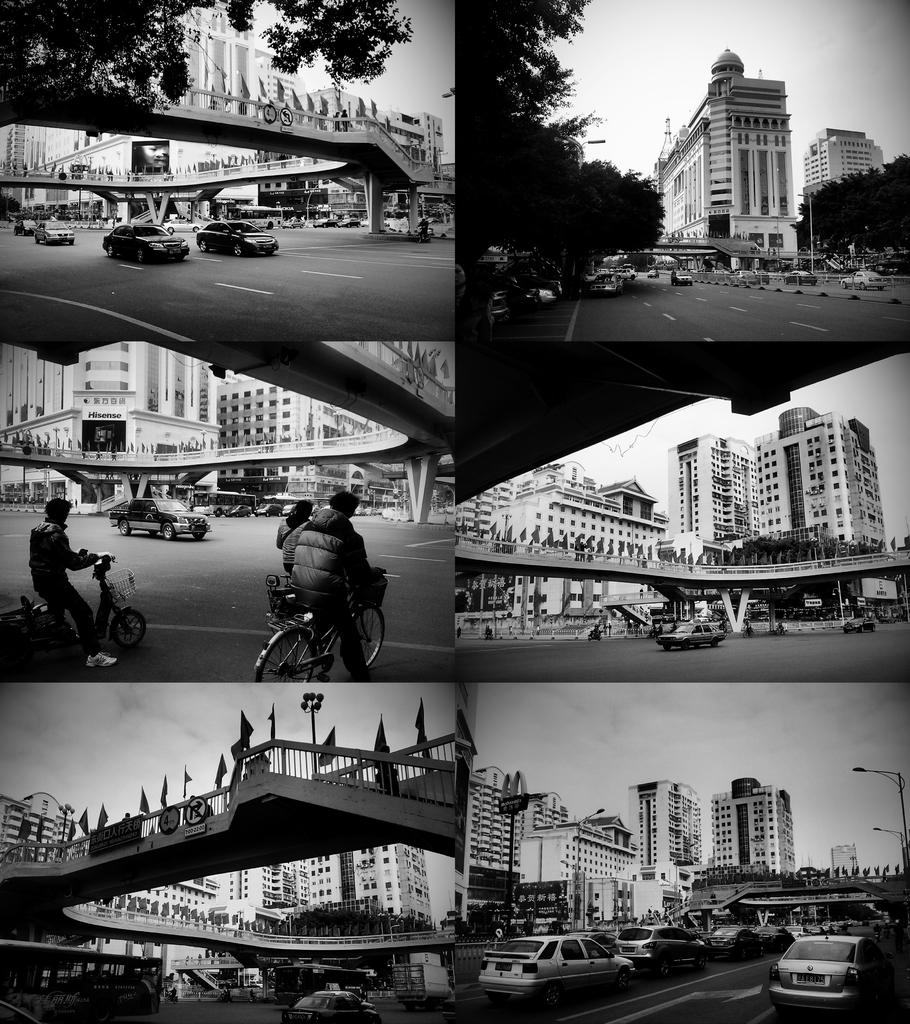What is happening under the bridge in the image? Cars are riding under the bridge, and people are riding bicycles under the bridge. What type of vehicles are in front of the building? The image does not specify the type of vehicles in front of the building, only that there are vehicles present. Can you see a girl riding a bicycle under the bridge? There is no girl present in the image; only cars and people riding bicycles are visible under the bridge. What flavor of mint is growing near the building? There is no mint present in the image; the focus is on the vehicles and people under the bridge and in front of the building. 